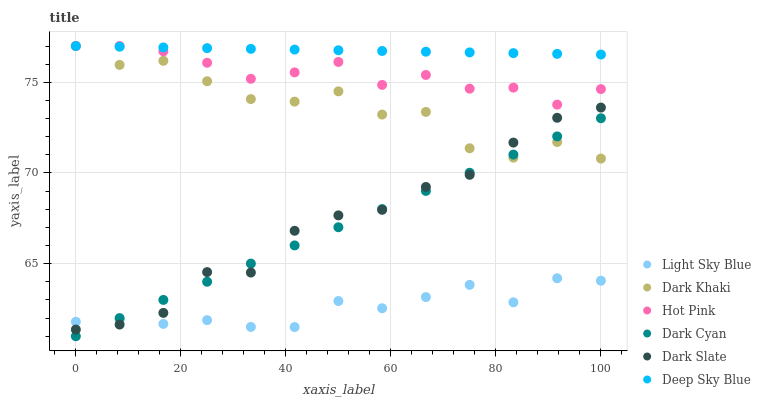Does Light Sky Blue have the minimum area under the curve?
Answer yes or no. Yes. Does Deep Sky Blue have the maximum area under the curve?
Answer yes or no. Yes. Does Dark Khaki have the minimum area under the curve?
Answer yes or no. No. Does Dark Khaki have the maximum area under the curve?
Answer yes or no. No. Is Deep Sky Blue the smoothest?
Answer yes or no. Yes. Is Dark Khaki the roughest?
Answer yes or no. Yes. Is Dark Slate the smoothest?
Answer yes or no. No. Is Dark Slate the roughest?
Answer yes or no. No. Does Dark Cyan have the lowest value?
Answer yes or no. Yes. Does Dark Khaki have the lowest value?
Answer yes or no. No. Does Deep Sky Blue have the highest value?
Answer yes or no. Yes. Does Dark Slate have the highest value?
Answer yes or no. No. Is Light Sky Blue less than Dark Khaki?
Answer yes or no. Yes. Is Hot Pink greater than Dark Slate?
Answer yes or no. Yes. Does Dark Khaki intersect Hot Pink?
Answer yes or no. Yes. Is Dark Khaki less than Hot Pink?
Answer yes or no. No. Is Dark Khaki greater than Hot Pink?
Answer yes or no. No. Does Light Sky Blue intersect Dark Khaki?
Answer yes or no. No. 